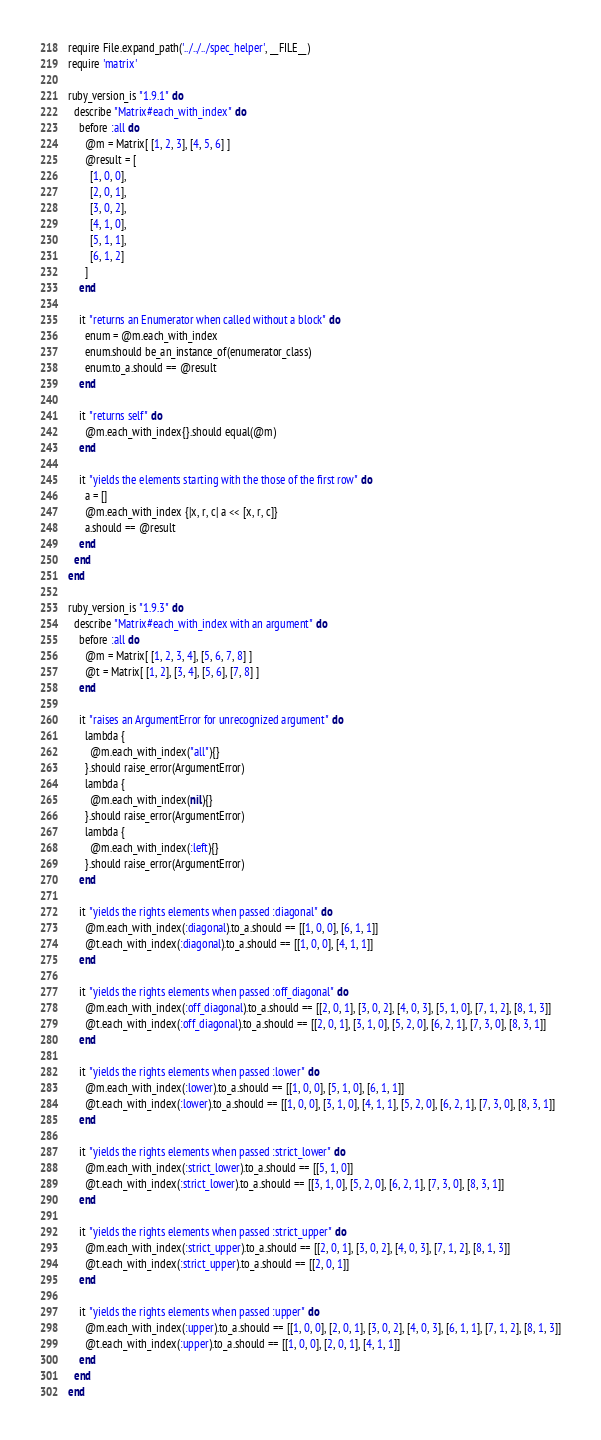<code> <loc_0><loc_0><loc_500><loc_500><_Ruby_>require File.expand_path('../../../spec_helper', __FILE__)
require 'matrix'

ruby_version_is "1.9.1" do
  describe "Matrix#each_with_index" do
    before :all do
      @m = Matrix[ [1, 2, 3], [4, 5, 6] ]
      @result = [
        [1, 0, 0],
        [2, 0, 1],
        [3, 0, 2],
        [4, 1, 0],
        [5, 1, 1],
        [6, 1, 2]
      ]
    end

    it "returns an Enumerator when called without a block" do
      enum = @m.each_with_index
      enum.should be_an_instance_of(enumerator_class)
      enum.to_a.should == @result
    end

    it "returns self" do
      @m.each_with_index{}.should equal(@m)
    end

    it "yields the elements starting with the those of the first row" do
      a = []
      @m.each_with_index {|x, r, c| a << [x, r, c]}
      a.should == @result
    end
  end
end

ruby_version_is "1.9.3" do
  describe "Matrix#each_with_index with an argument" do
    before :all do
      @m = Matrix[ [1, 2, 3, 4], [5, 6, 7, 8] ]
      @t = Matrix[ [1, 2], [3, 4], [5, 6], [7, 8] ]
    end

    it "raises an ArgumentError for unrecognized argument" do
      lambda {
        @m.each_with_index("all"){}
      }.should raise_error(ArgumentError)
      lambda {
        @m.each_with_index(nil){}
      }.should raise_error(ArgumentError)
      lambda {
        @m.each_with_index(:left){}
      }.should raise_error(ArgumentError)
    end

    it "yields the rights elements when passed :diagonal" do
      @m.each_with_index(:diagonal).to_a.should == [[1, 0, 0], [6, 1, 1]]
      @t.each_with_index(:diagonal).to_a.should == [[1, 0, 0], [4, 1, 1]]
    end

    it "yields the rights elements when passed :off_diagonal" do
      @m.each_with_index(:off_diagonal).to_a.should == [[2, 0, 1], [3, 0, 2], [4, 0, 3], [5, 1, 0], [7, 1, 2], [8, 1, 3]]
      @t.each_with_index(:off_diagonal).to_a.should == [[2, 0, 1], [3, 1, 0], [5, 2, 0], [6, 2, 1], [7, 3, 0], [8, 3, 1]]
    end

    it "yields the rights elements when passed :lower" do
      @m.each_with_index(:lower).to_a.should == [[1, 0, 0], [5, 1, 0], [6, 1, 1]]
      @t.each_with_index(:lower).to_a.should == [[1, 0, 0], [3, 1, 0], [4, 1, 1], [5, 2, 0], [6, 2, 1], [7, 3, 0], [8, 3, 1]]
    end

    it "yields the rights elements when passed :strict_lower" do
      @m.each_with_index(:strict_lower).to_a.should == [[5, 1, 0]]
      @t.each_with_index(:strict_lower).to_a.should == [[3, 1, 0], [5, 2, 0], [6, 2, 1], [7, 3, 0], [8, 3, 1]]
    end

    it "yields the rights elements when passed :strict_upper" do
      @m.each_with_index(:strict_upper).to_a.should == [[2, 0, 1], [3, 0, 2], [4, 0, 3], [7, 1, 2], [8, 1, 3]]
      @t.each_with_index(:strict_upper).to_a.should == [[2, 0, 1]]
    end

    it "yields the rights elements when passed :upper" do
      @m.each_with_index(:upper).to_a.should == [[1, 0, 0], [2, 0, 1], [3, 0, 2], [4, 0, 3], [6, 1, 1], [7, 1, 2], [8, 1, 3]]
      @t.each_with_index(:upper).to_a.should == [[1, 0, 0], [2, 0, 1], [4, 1, 1]]
    end
  end
end
</code> 